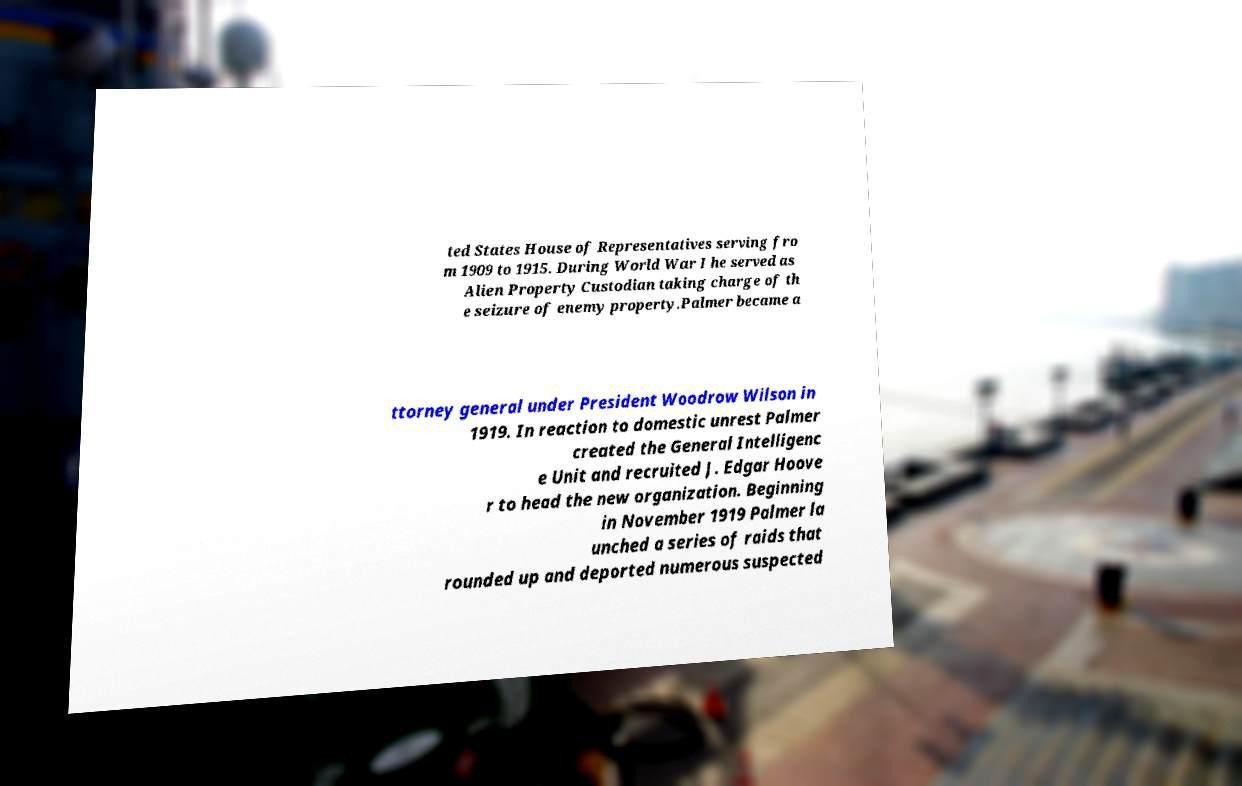Can you read and provide the text displayed in the image?This photo seems to have some interesting text. Can you extract and type it out for me? ted States House of Representatives serving fro m 1909 to 1915. During World War I he served as Alien Property Custodian taking charge of th e seizure of enemy property.Palmer became a ttorney general under President Woodrow Wilson in 1919. In reaction to domestic unrest Palmer created the General Intelligenc e Unit and recruited J. Edgar Hoove r to head the new organization. Beginning in November 1919 Palmer la unched a series of raids that rounded up and deported numerous suspected 